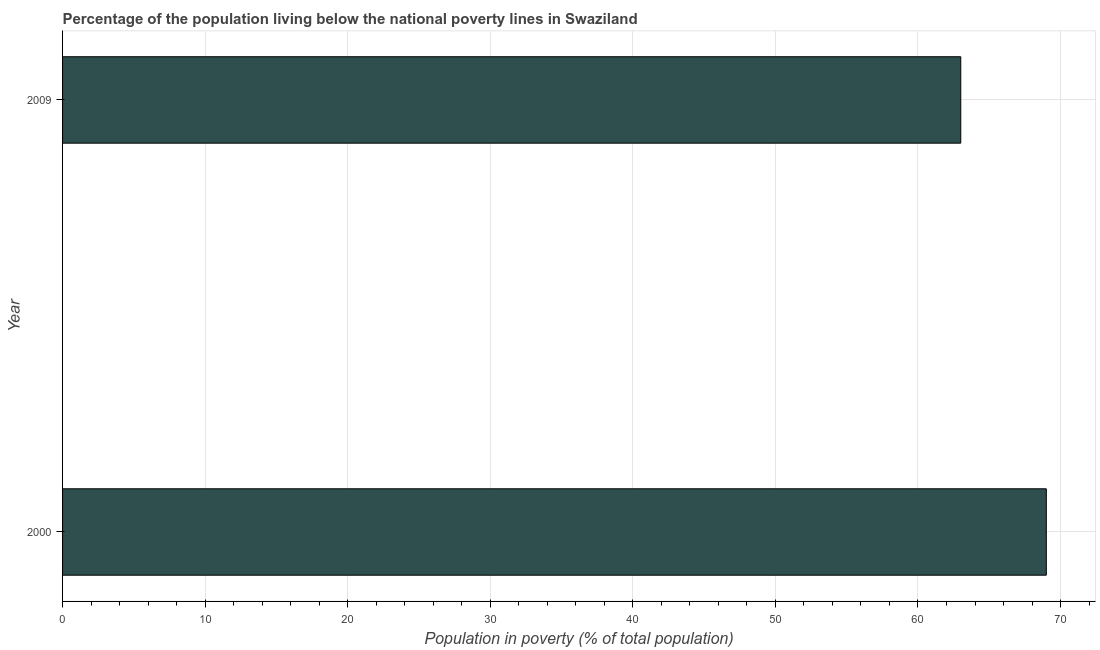Does the graph contain any zero values?
Offer a terse response. No. Does the graph contain grids?
Provide a short and direct response. Yes. What is the title of the graph?
Your response must be concise. Percentage of the population living below the national poverty lines in Swaziland. What is the label or title of the X-axis?
Make the answer very short. Population in poverty (% of total population). What is the label or title of the Y-axis?
Ensure brevity in your answer.  Year. What is the percentage of population living below poverty line in 2000?
Your response must be concise. 69. In which year was the percentage of population living below poverty line maximum?
Make the answer very short. 2000. What is the sum of the percentage of population living below poverty line?
Offer a terse response. 132. What is the difference between the percentage of population living below poverty line in 2000 and 2009?
Offer a very short reply. 6. What is the average percentage of population living below poverty line per year?
Keep it short and to the point. 66. What is the ratio of the percentage of population living below poverty line in 2000 to that in 2009?
Make the answer very short. 1.09. What is the difference between two consecutive major ticks on the X-axis?
Provide a short and direct response. 10. Are the values on the major ticks of X-axis written in scientific E-notation?
Your response must be concise. No. What is the difference between the Population in poverty (% of total population) in 2000 and 2009?
Provide a short and direct response. 6. What is the ratio of the Population in poverty (% of total population) in 2000 to that in 2009?
Provide a succinct answer. 1.09. 